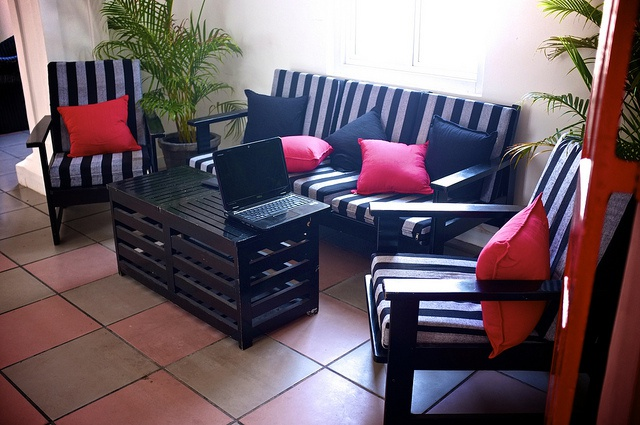Describe the objects in this image and their specific colors. I can see chair in lightpink, black, brown, maroon, and navy tones, couch in lightpink, navy, black, darkblue, and gray tones, potted plant in lightpink, black, gray, and darkgreen tones, potted plant in lightpink, black, lightgray, darkgray, and darkgreen tones, and laptop in lightpink, black, navy, gray, and darkblue tones in this image. 